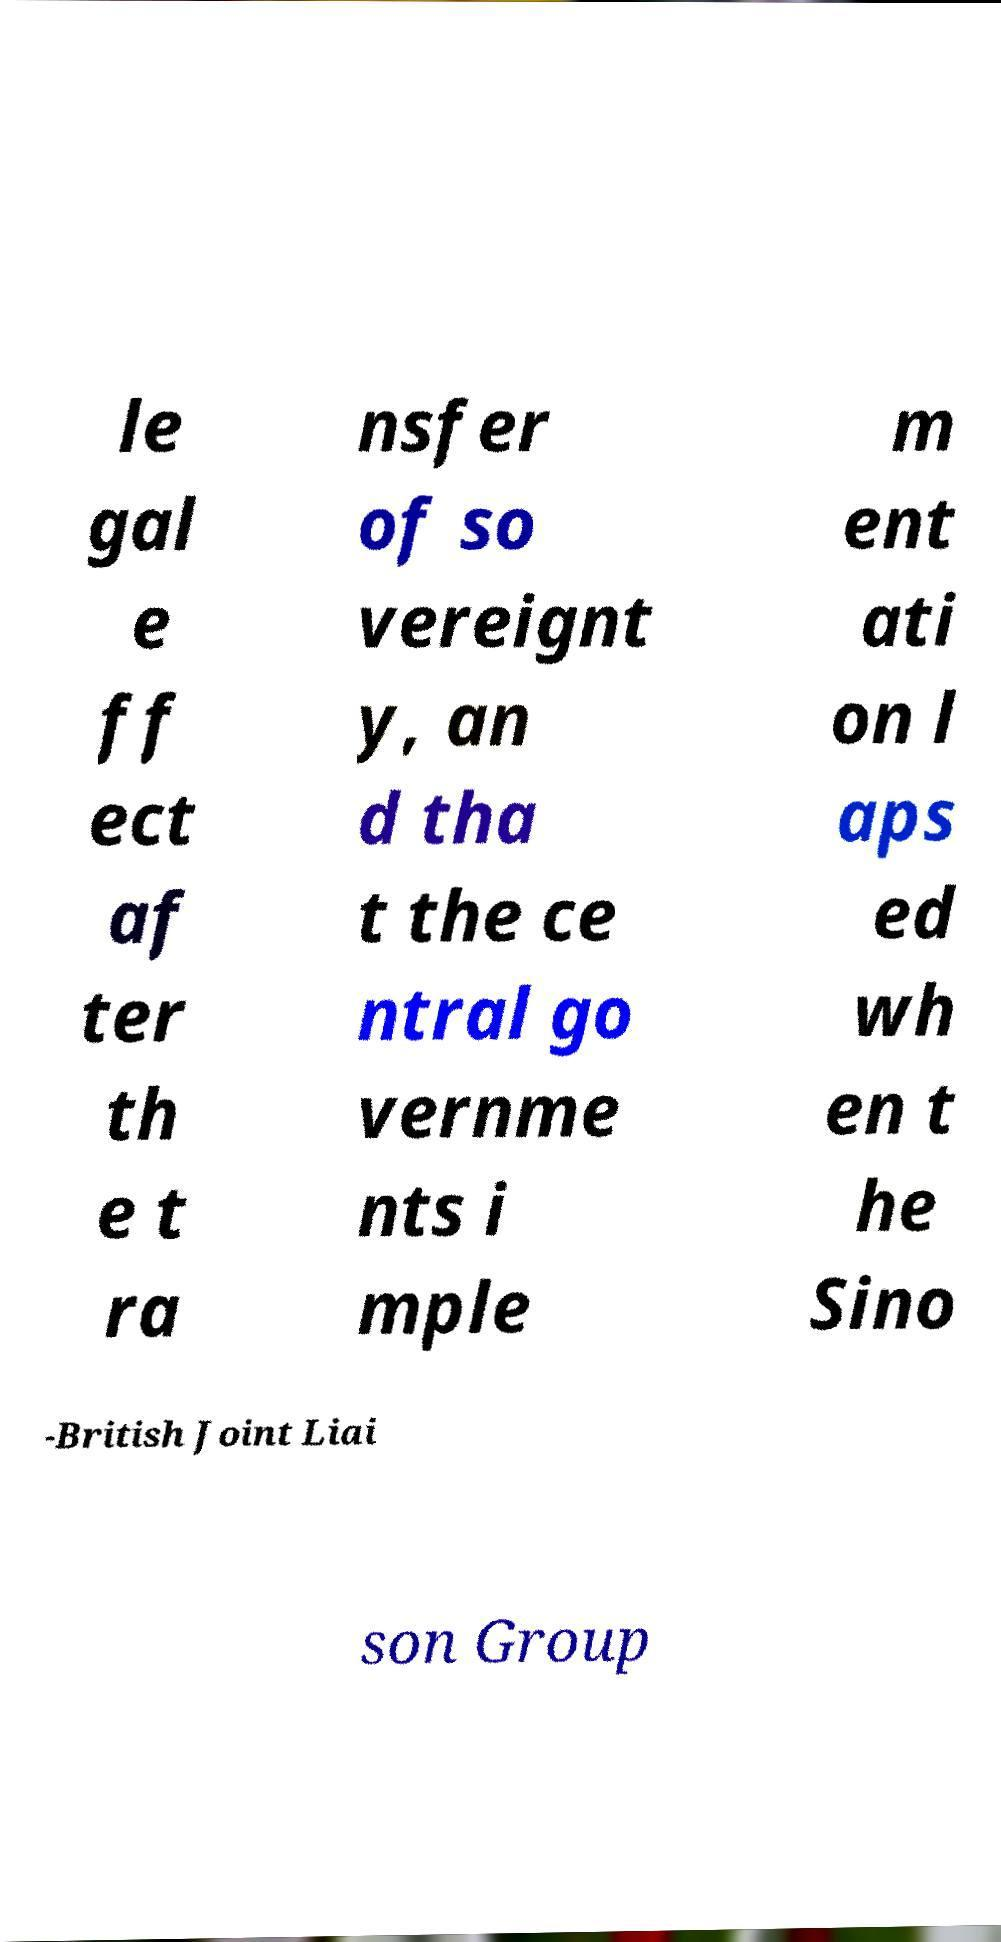There's text embedded in this image that I need extracted. Can you transcribe it verbatim? le gal e ff ect af ter th e t ra nsfer of so vereignt y, an d tha t the ce ntral go vernme nts i mple m ent ati on l aps ed wh en t he Sino -British Joint Liai son Group 